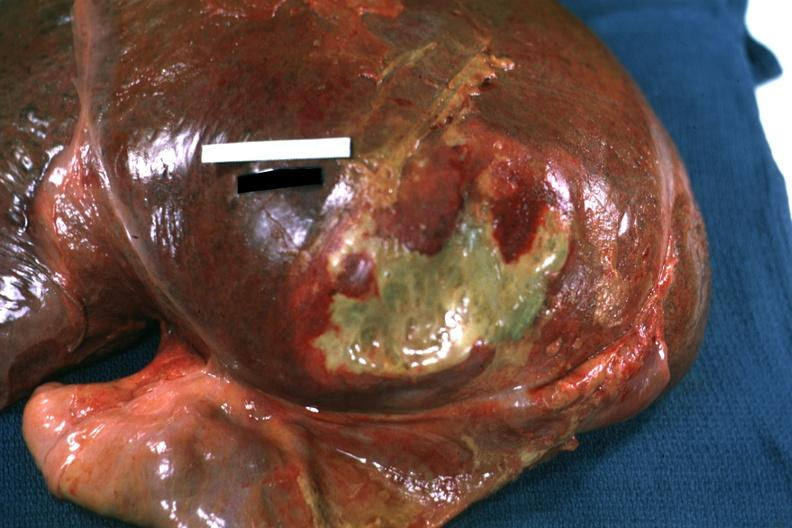s liver present?
Answer the question using a single word or phrase. Yes 